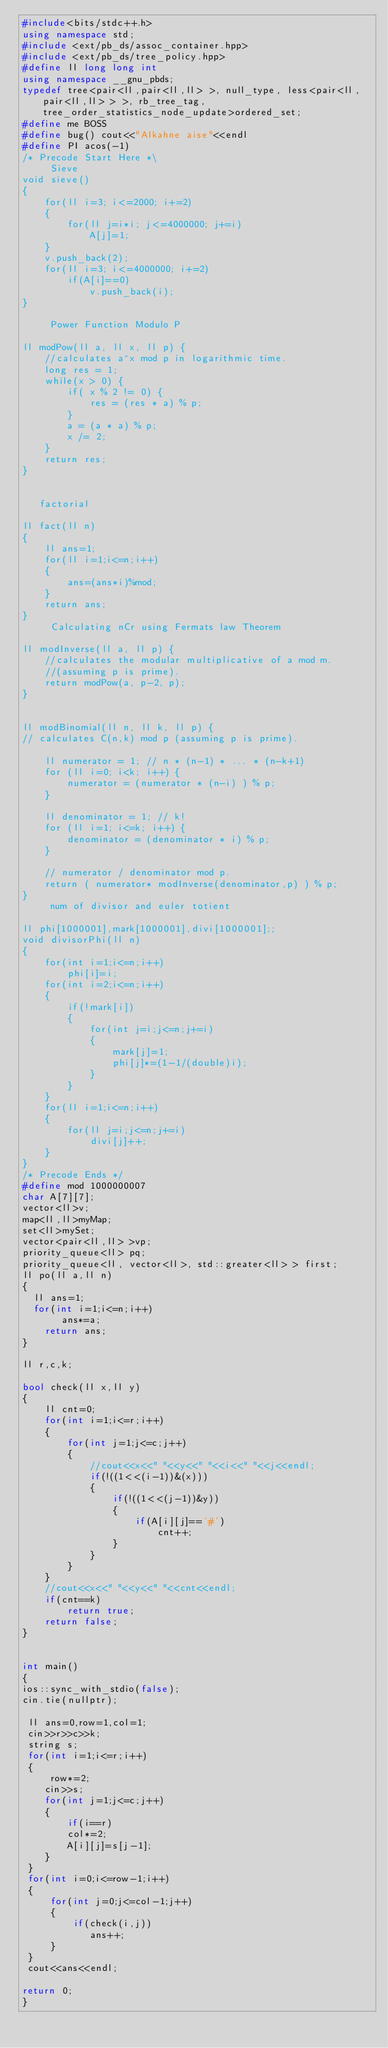Convert code to text. <code><loc_0><loc_0><loc_500><loc_500><_C++_>#include<bits/stdc++.h>
using namespace std;
#include <ext/pb_ds/assoc_container.hpp>
#include <ext/pb_ds/tree_policy.hpp>
#define ll long long int
using namespace __gnu_pbds;
typedef tree<pair<ll,pair<ll,ll> >, null_type, less<pair<ll,pair<ll,ll> > >, rb_tree_tag, tree_order_statistics_node_update>ordered_set;
#define me BOSS
#define bug() cout<<"AIkahne aise"<<endl
#define PI acos(-1)
/* Precode Start Here *\
     Sieve
void sieve()
{
    for(ll i=3; i<=2000; i+=2)
    {
        for(ll j=i*i; j<=4000000; j+=i)
            A[j]=1;
    }
    v.push_back(2);
    for(ll i=3; i<=4000000; i+=2)
        if(A[i]==0)
            v.push_back(i);
}

     Power Function Modulo P

ll modPow(ll a, ll x, ll p) {
    //calculates a^x mod p in logarithmic time.
    long res = 1;
    while(x > 0) {
        if( x % 2 != 0) {
            res = (res * a) % p;
        }
        a = (a * a) % p;
        x /= 2;
    }
    return res;
}


   factorial

ll fact(ll n)
{
    ll ans=1;
    for(ll i=1;i<=n;i++)
    {
        ans=(ans*i)%mod;
    }
    return ans;
}
     Calculating nCr using Fermats law Theorem

ll modInverse(ll a, ll p) {
    //calculates the modular multiplicative of a mod m.
    //(assuming p is prime).
    return modPow(a, p-2, p);
}


ll modBinomial(ll n, ll k, ll p) {
// calculates C(n,k) mod p (assuming p is prime).

    ll numerator = 1; // n * (n-1) * ... * (n-k+1)
    for (ll i=0; i<k; i++) {
        numerator = (numerator * (n-i) ) % p;
    }

    ll denominator = 1; // k!
    for (ll i=1; i<=k; i++) {
        denominator = (denominator * i) % p;
    }

    // numerator / denominator mod p.
    return ( numerator* modInverse(denominator,p) ) % p;
}
     num of divisor and euler totient

ll phi[1000001],mark[1000001],divi[1000001];;
void divisorPhi(ll n)
{
    for(int i=1;i<=n;i++)
        phi[i]=i;
    for(int i=2;i<=n;i++)
    {
        if(!mark[i])
        {
            for(int j=i;j<=n;j+=i)
            {
                mark[j]=1;
                phi[j]*=(1-1/(double)i);
            }
        }
    }
    for(ll i=1;i<=n;i++)
    {
        for(ll j=i;j<=n;j+=i)
            divi[j]++;
    }
}
/* Precode Ends */
#define mod 1000000007
char A[7][7];
vector<ll>v;
map<ll,ll>myMap;
set<ll>mySet;
vector<pair<ll,ll> >vp;
priority_queue<ll> pq;
priority_queue<ll, vector<ll>, std::greater<ll> > first;
ll po(ll a,ll n)
{
  ll ans=1;
  for(int i=1;i<=n;i++)
       ans*=a;
    return ans;
}

ll r,c,k;

bool check(ll x,ll y)
{
    ll cnt=0;
    for(int i=1;i<=r;i++)
    {
        for(int j=1;j<=c;j++)
        {
            //cout<<x<<" "<<y<<" "<<i<<" "<<j<<endl;
            if(!((1<<(i-1))&(x)))
            {
                if(!((1<<(j-1))&y))
                {
                    if(A[i][j]=='#')
                        cnt++;
                }
            }
        }
    }
    //cout<<x<<" "<<y<<" "<<cnt<<endl;
    if(cnt==k)
        return true;
    return false;
}


int main()
{
ios::sync_with_stdio(false);
cin.tie(nullptr);

 ll ans=0,row=1,col=1;
 cin>>r>>c>>k;
 string s;
 for(int i=1;i<=r;i++)
 {
     row*=2;
    cin>>s;
    for(int j=1;j<=c;j++)
    {
        if(i==r)
        col*=2;
        A[i][j]=s[j-1];
    }
 }
 for(int i=0;i<=row-1;i++)
 {
     for(int j=0;j<=col-1;j++)
     {
         if(check(i,j))
            ans++;
     }
 }
 cout<<ans<<endl;

return 0;
}

</code> 